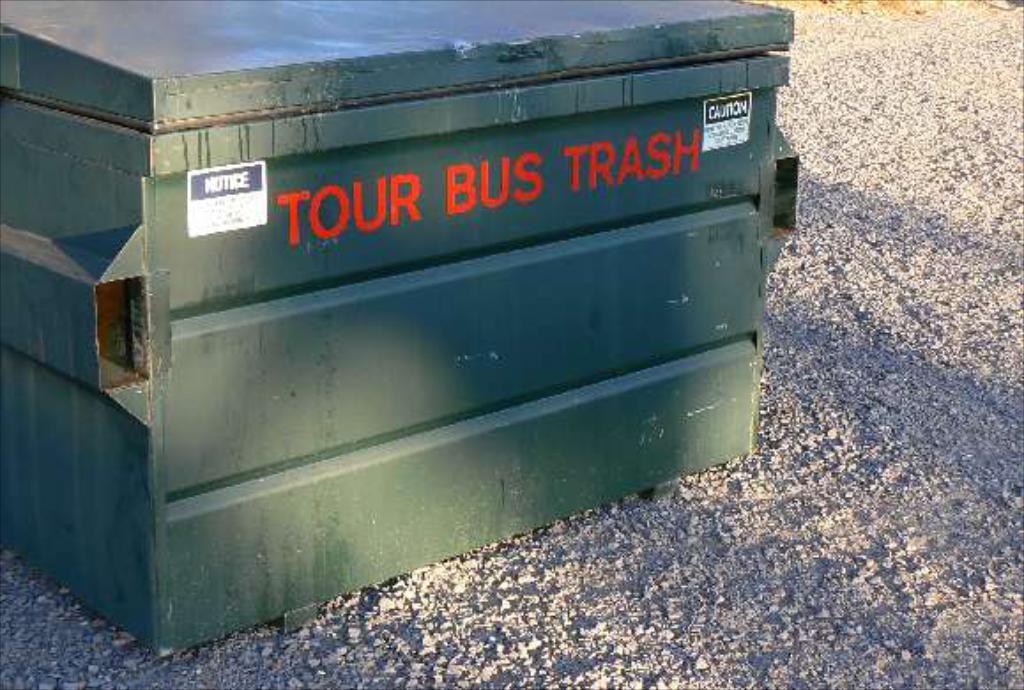What kind of trash is this for?
Offer a very short reply. Tour bus. What type of material is this trash box made of?
Provide a succinct answer. Unanswerable. 